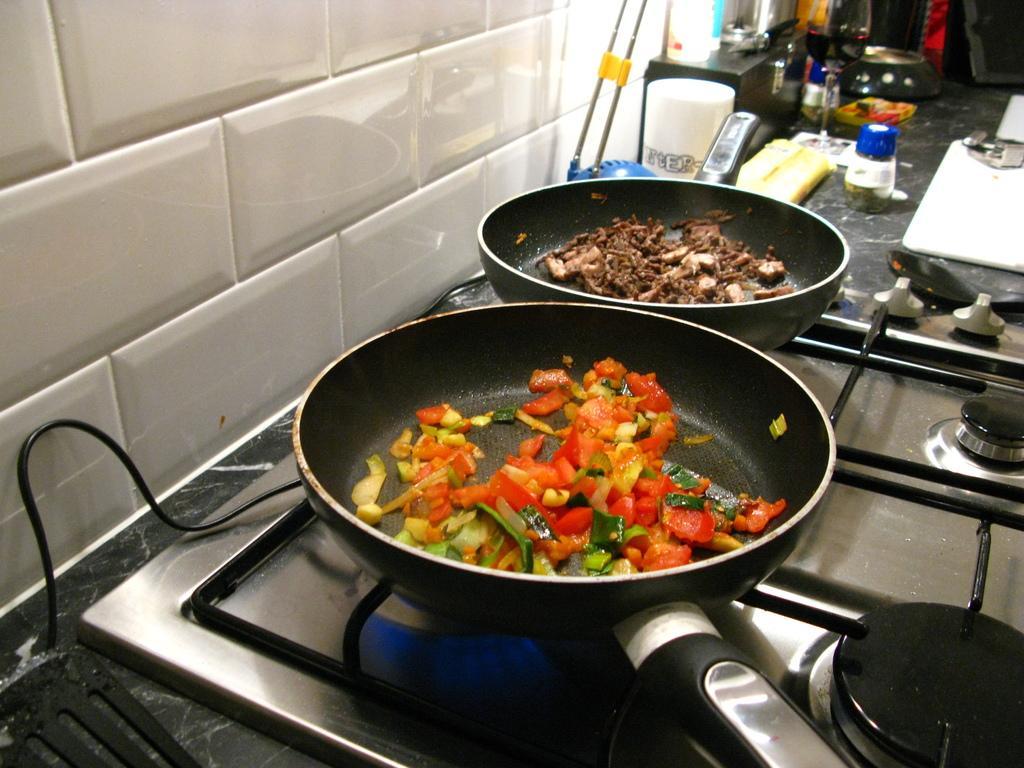How would you summarize this image in a sentence or two? In this image, I can see the food items in the frying pans, which are on the stove. In the background, I can see a wine glass, bottles, serving spoon and few other things. On the left side of the image, I can see a wire and a wall. 